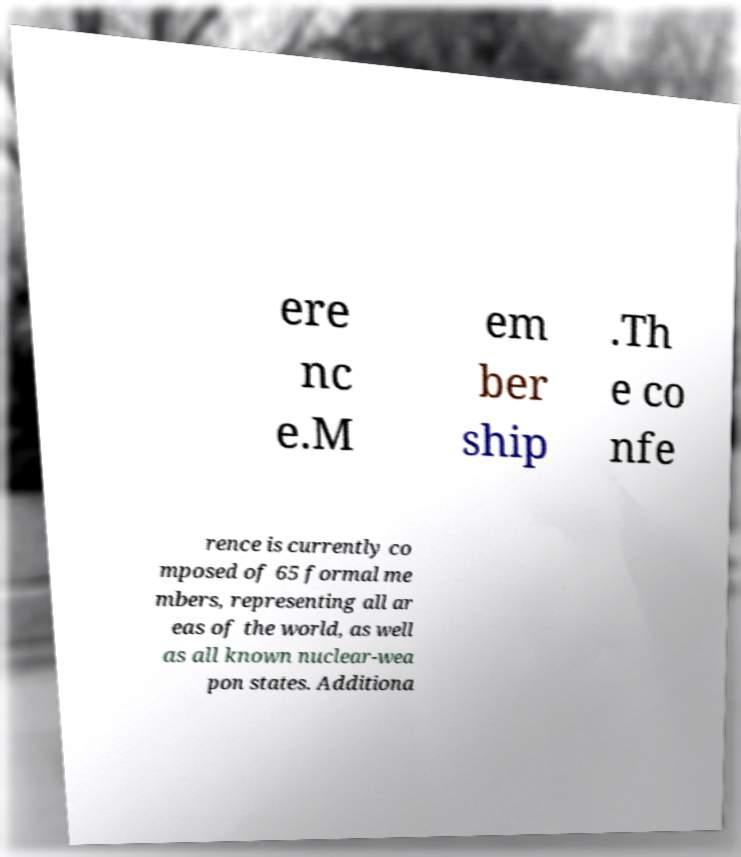Can you accurately transcribe the text from the provided image for me? ere nc e.M em ber ship .Th e co nfe rence is currently co mposed of 65 formal me mbers, representing all ar eas of the world, as well as all known nuclear-wea pon states. Additiona 